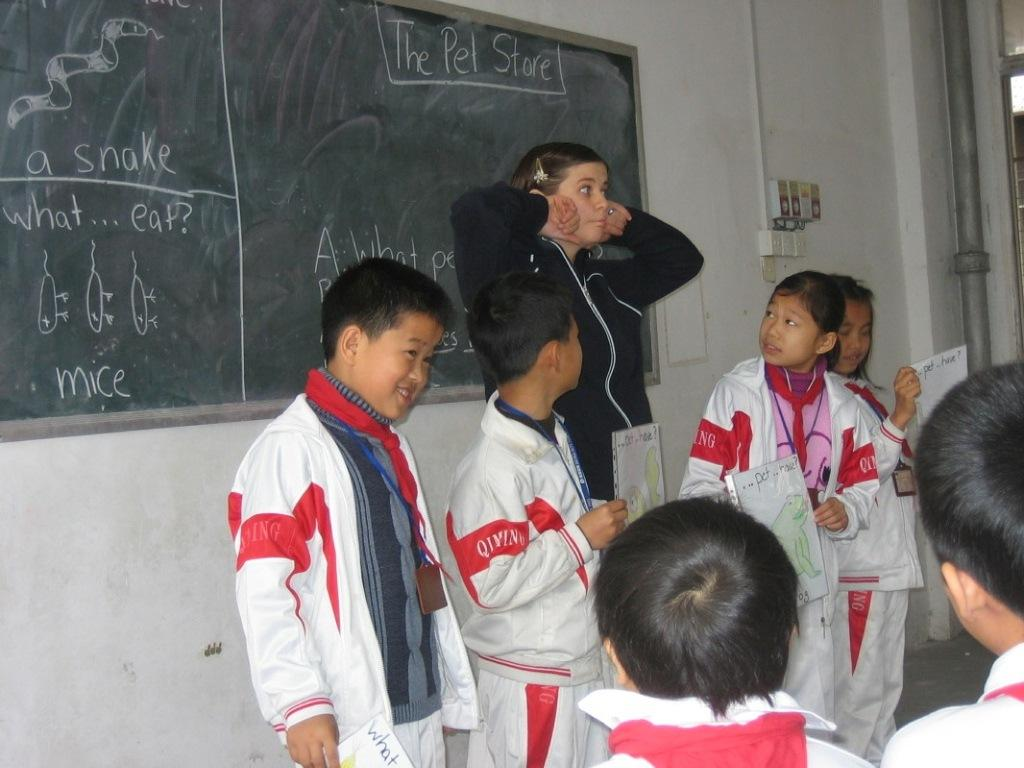<image>
Give a short and clear explanation of the subsequent image. a group of students with the word snake behind them 